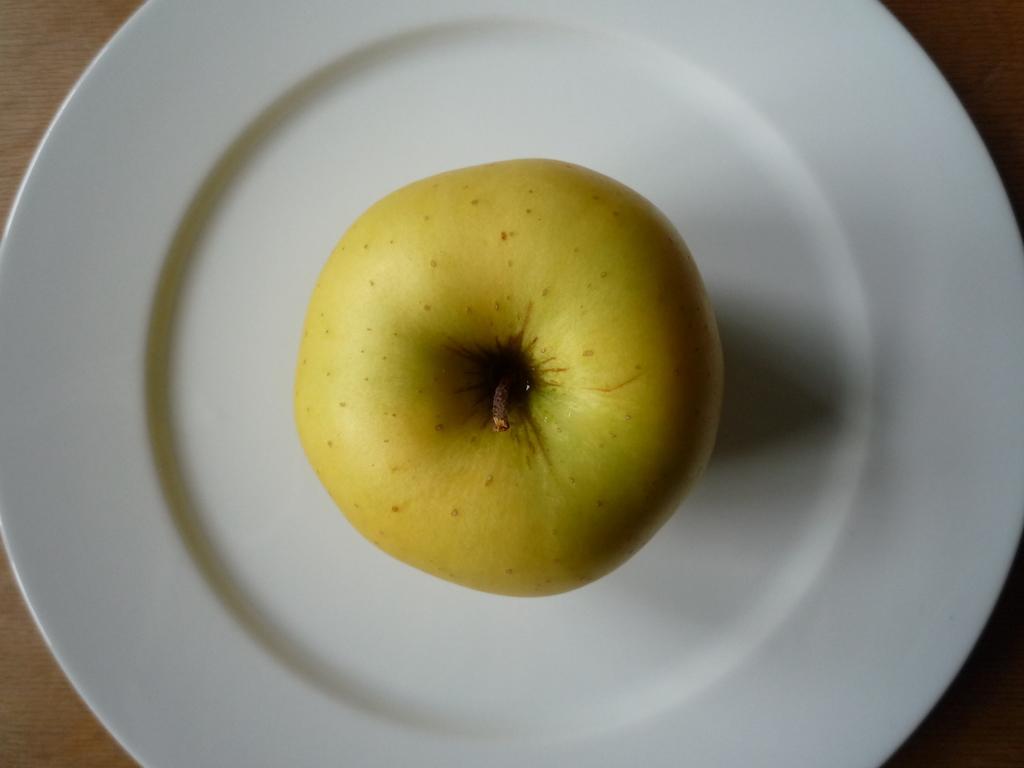Can you describe this image briefly? In this image there is a fruit on the plate. 